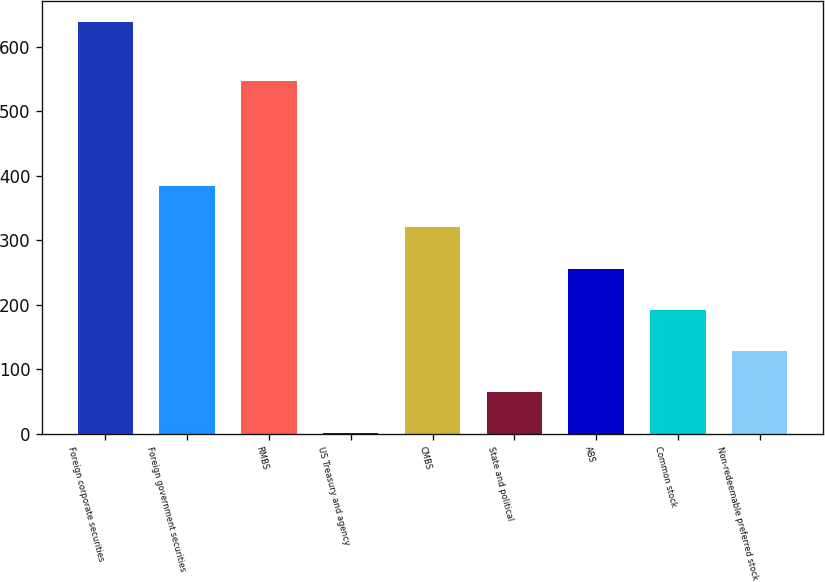Convert chart. <chart><loc_0><loc_0><loc_500><loc_500><bar_chart><fcel>Foreign corporate securities<fcel>Foreign government securities<fcel>RMBS<fcel>US Treasury and agency<fcel>CMBS<fcel>State and political<fcel>ABS<fcel>Common stock<fcel>Non-redeemable preferred stock<nl><fcel>639<fcel>383.8<fcel>547<fcel>1<fcel>320<fcel>64.8<fcel>256.2<fcel>192.4<fcel>128.6<nl></chart> 